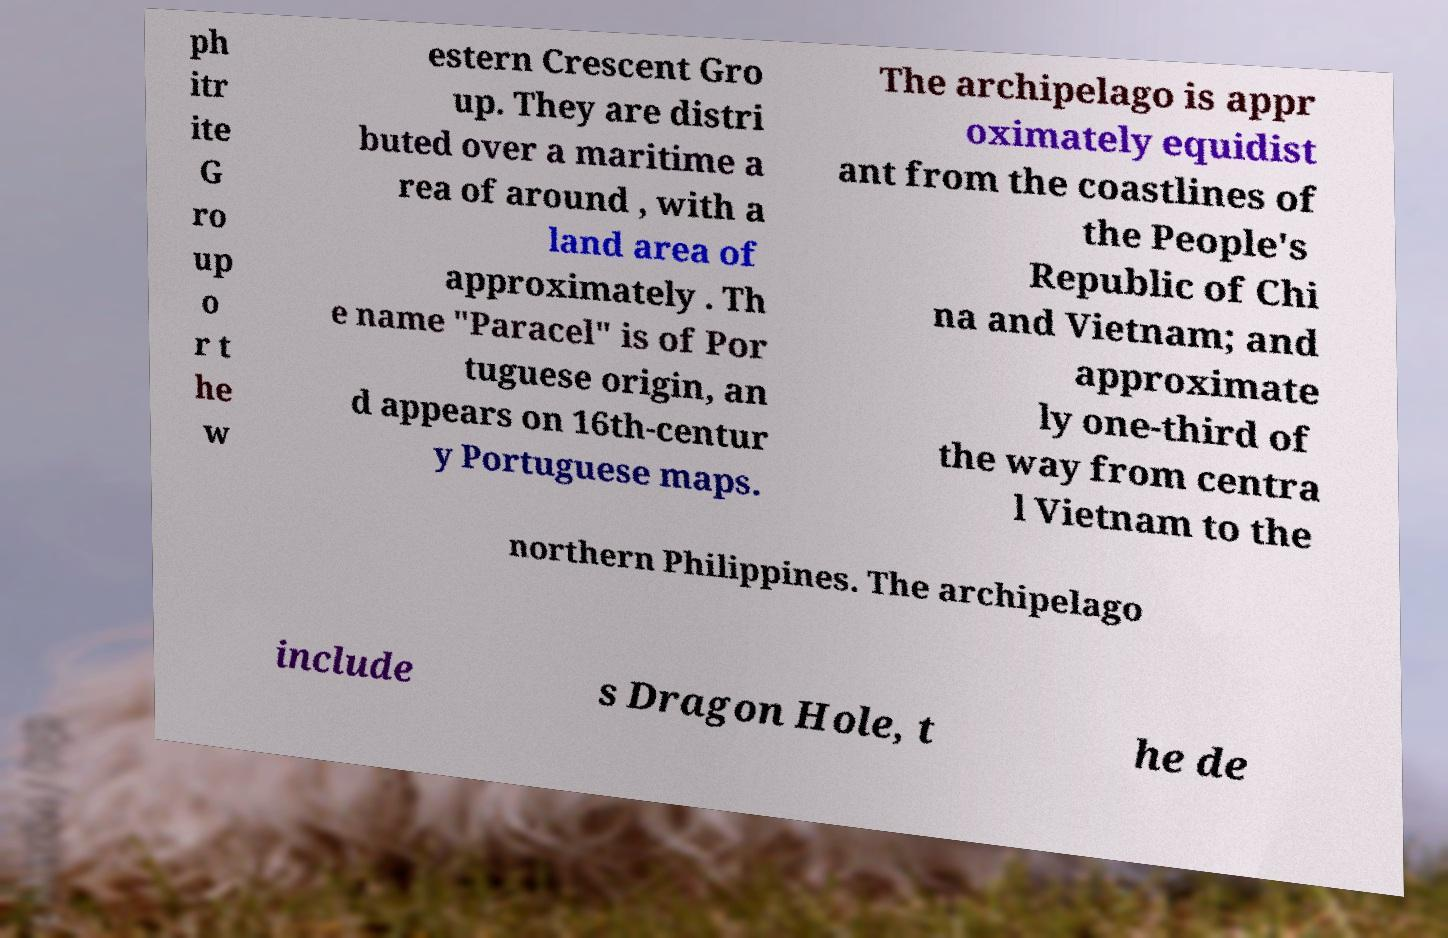Can you read and provide the text displayed in the image?This photo seems to have some interesting text. Can you extract and type it out for me? ph itr ite G ro up o r t he w estern Crescent Gro up. They are distri buted over a maritime a rea of around , with a land area of approximately . Th e name "Paracel" is of Por tuguese origin, an d appears on 16th-centur y Portuguese maps. The archipelago is appr oximately equidist ant from the coastlines of the People's Republic of Chi na and Vietnam; and approximate ly one-third of the way from centra l Vietnam to the northern Philippines. The archipelago include s Dragon Hole, t he de 